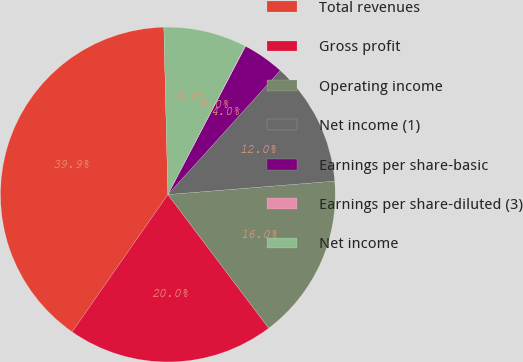Convert chart. <chart><loc_0><loc_0><loc_500><loc_500><pie_chart><fcel>Total revenues<fcel>Gross profit<fcel>Operating income<fcel>Net income (1)<fcel>Earnings per share-basic<fcel>Earnings per share-diluted (3)<fcel>Net income<nl><fcel>39.93%<fcel>19.98%<fcel>15.99%<fcel>12.01%<fcel>4.03%<fcel>0.04%<fcel>8.02%<nl></chart> 